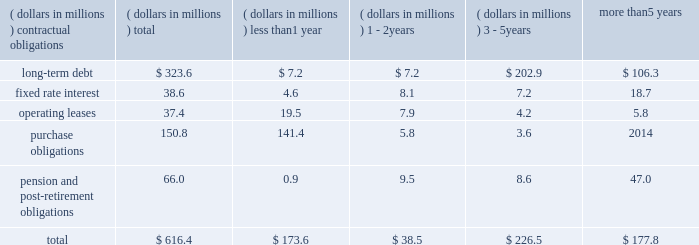In november 2016 , we issued $ 45 million of fixed rate term notes in two tranches to two insurance companies .
Principal payments commence in 2023 and 2028 and the notes mature in 2029 and 2034 , respectively .
The notes carry interest rates of 2.87 and 3.10 , respectively .
We used proceeds of the notes to pay down borrowings under our revolving credit facility .
In january 2015 , we issued $ 75 million of fixed rate term notes to an insurance company .
Principal payments commence in 2020 and the notes mature in 2030 .
The notes carry an interest rate of 3.52 percent .
We used proceeds of the notes to pay down borrowings under our revolving credit facility .
At december 31 , 2016 , we had available borrowing capacity of $ 310.8 million under this facility .
We believe that the combination of cash , available borrowing capacity and operating cash flow will provide sufficient funds to finance our existing operations for the foreseeable future .
Our total debt increased to $ 323.6 million at december 31 , 2016 compared with $ 249.0 million at december 31 , 2015 , as our cash flows generated in the u.s were more than offset by our share repurchase activity and our purchase of aquasana .
As a result , our leverage , as measured by the ratio of total debt to total capitalization , was 17.6 percent at the end of 2016 compared with 14.7 percent at the end of 2015 .
Our u.s .
Pension plan continues to meet all funding requirements under erisa regulations .
We were not required to make a contribution to our pension plan in 2016 but made a voluntary $ 30 million contribution due to escalating pension benefit guaranty corporation insurance premiums .
We forecast that we will not be required to make a contribution to the plan in 2017 and we do not plan to make any voluntary contributions in 2017 .
For further information on our pension plans , see note 10 of the notes to consolidated financial statements .
During 2016 , our board of directors authorized the purchase of an additional 3000000 shares of our common stock .
In 2016 , we repurchased 3273109 shares at an average price of $ 41.30 per share and a total cost of $ 135.2 million .
A total of 4906403 shares remained on the existing repurchase authorization at december 31 , 2016 .
Depending on factors such as stock price , working capital requirements and alternative investment opportunities , such as acquisitions , we expect to spend approximately $ 135 million on share repurchase activity in 2017 using a 10b5-1 repurchase plan .
In addition , we may opportunistically repurchase an additional $ 65 million of our shares in 2017 .
We have paid dividends for 77 consecutive years with payments increasing each of the last 25 years .
We paid dividends of $ 0.48 per share in 2016 compared with $ 0.38 per share in 2015 .
In january 2017 , we increased our dividend by 17 percent and anticipate paying dividends of $ 0.56 per share in 2017 .
Aggregate contractual obligations a summary of our contractual obligations as of december 31 , 2016 , is as follows: .
As of december 31 , 2016 , our liability for uncertain income tax positions was $ 4.2 million .
Due to the high degree of uncertainty regarding timing of potential future cash flows associated with these liabilities , we are unable to make a reasonably reliable estimate of the amount and period in which these liabilities might be paid .
We utilize blanket purchase orders to communicate expected annual requirements to many of our suppliers .
Requirements under blanket purchase orders generally do not become committed until several weeks prior to our scheduled unit production .
The purchase obligation amount presented above represents the value of commitments that we consider firm .
Recent accounting pronouncements refer to recent accounting pronouncements in note 1 of notes to consolidated financial statements. .
What percentage of total aggregate contractual obligations is due to pension and post-retirement obligations? 
Computations: (66.0 / 616.4)
Answer: 0.10707. 